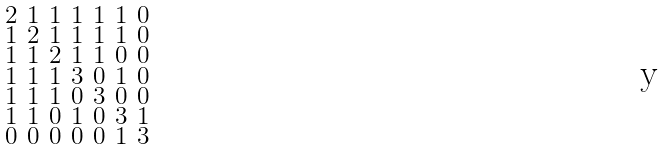Convert formula to latex. <formula><loc_0><loc_0><loc_500><loc_500>\begin{smallmatrix} 2 & 1 & 1 & 1 & 1 & 1 & 0 \\ 1 & 2 & 1 & 1 & 1 & 1 & 0 \\ 1 & 1 & 2 & 1 & 1 & 0 & 0 \\ 1 & 1 & 1 & 3 & 0 & 1 & 0 \\ 1 & 1 & 1 & 0 & 3 & 0 & 0 \\ 1 & 1 & 0 & 1 & 0 & 3 & 1 \\ 0 & 0 & 0 & 0 & 0 & 1 & 3 \end{smallmatrix}</formula> 